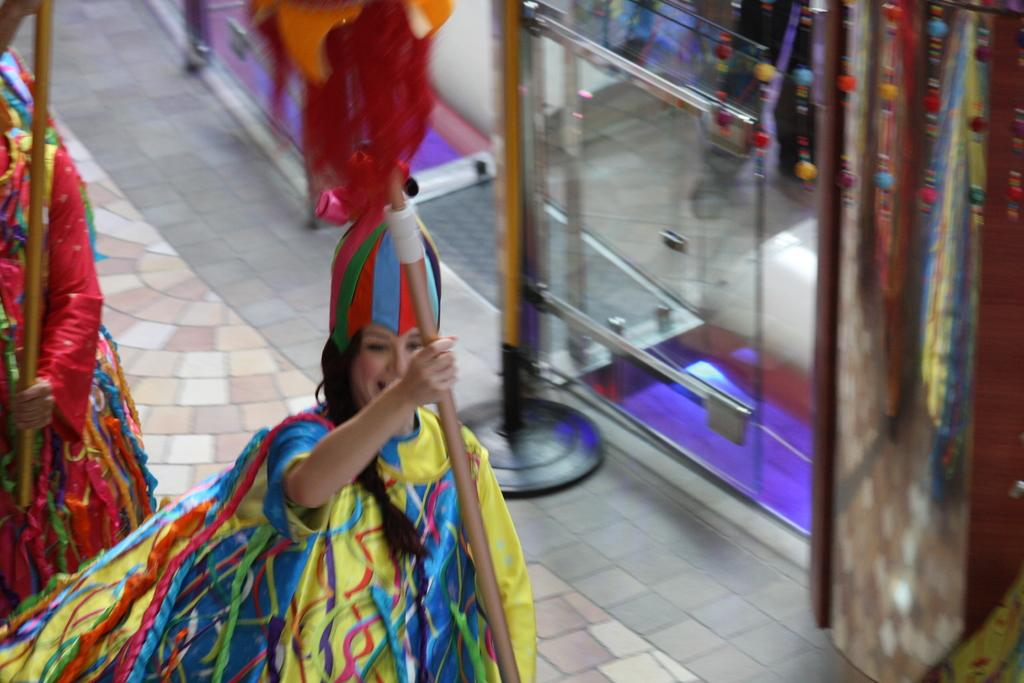How many people are in the image? There are two persons in the image. What are the persons doing in the image? The persons are standing in the image. What are the persons holding in the image? The persons are holding wooden sticks in the image. What can be seen in the background of the image? There are objects in the background of the image. What advice is the person on the left giving to the person on the right in the image? There is no indication in the image that the persons are giving or receiving advice. 